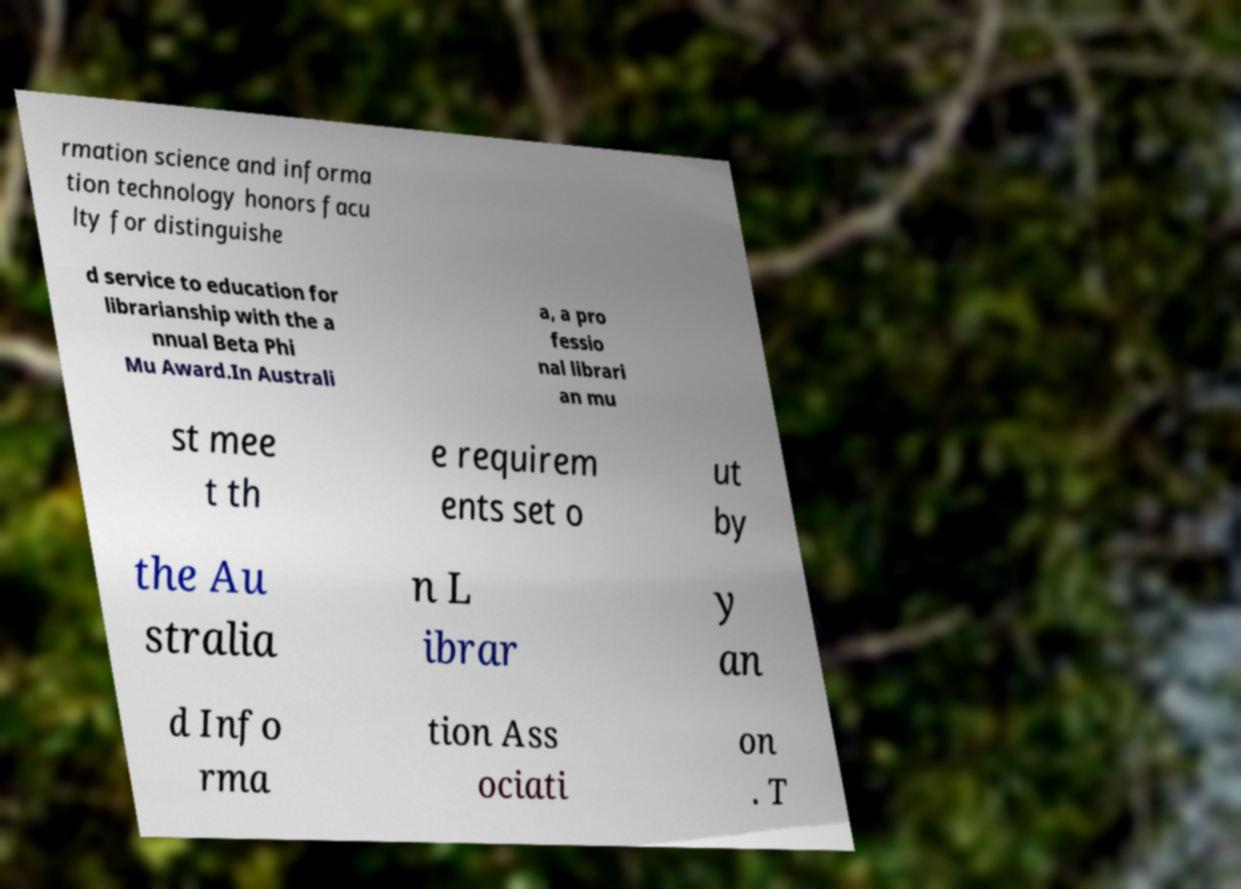What messages or text are displayed in this image? I need them in a readable, typed format. rmation science and informa tion technology honors facu lty for distinguishe d service to education for librarianship with the a nnual Beta Phi Mu Award.In Australi a, a pro fessio nal librari an mu st mee t th e requirem ents set o ut by the Au stralia n L ibrar y an d Info rma tion Ass ociati on . T 